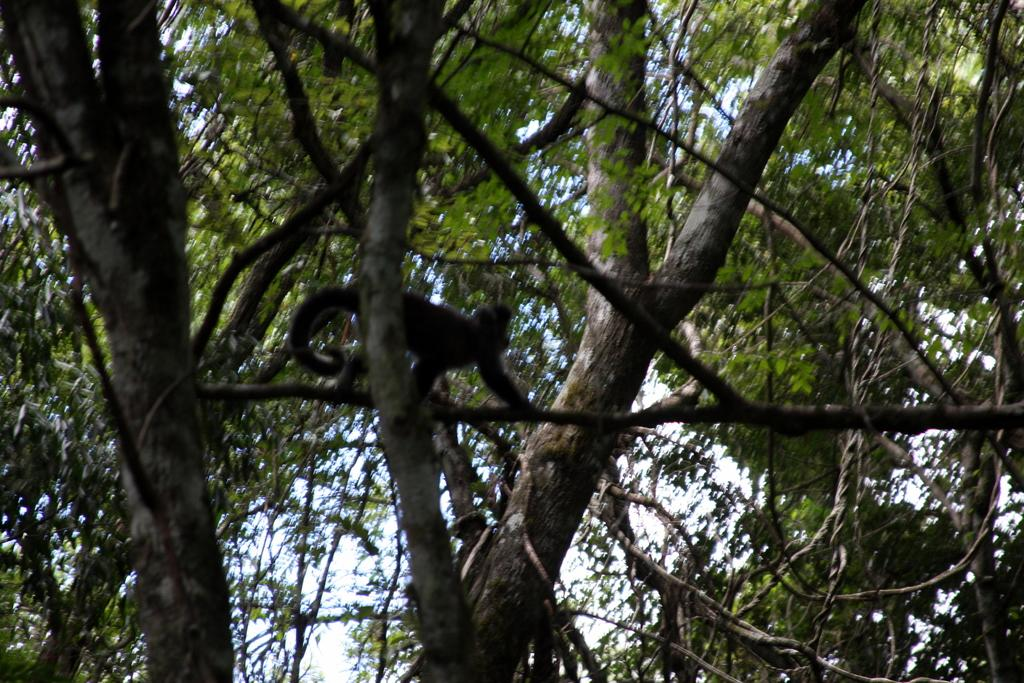What animal is present in the image? There is a monkey in the image. What is the monkey doing in the image? The monkey is walking on a tree stem. What can be seen in the background of the image? There are trees and the sky visible in the background of the image. What type of advertisement can be seen on the tree in the image? There is no advertisement present in the image; it features a monkey walking on a tree stem. What kind of pump is visible in the image? There is no pump present in the image. 